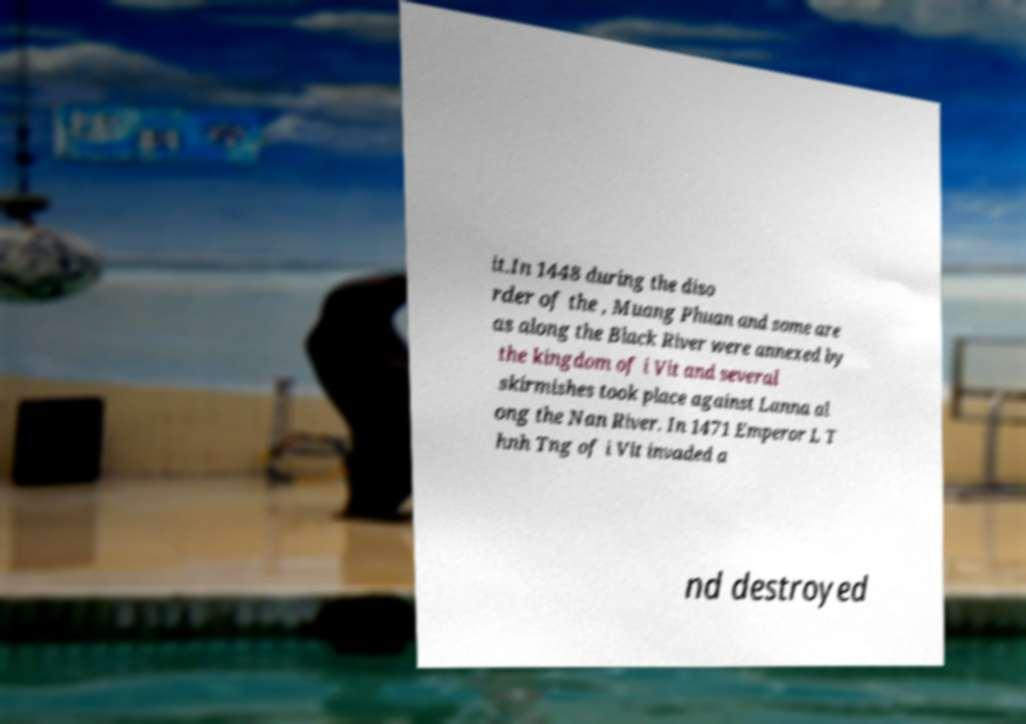Please identify and transcribe the text found in this image. it.In 1448 during the diso rder of the , Muang Phuan and some are as along the Black River were annexed by the kingdom of i Vit and several skirmishes took place against Lanna al ong the Nan River. In 1471 Emperor L T hnh Tng of i Vit invaded a nd destroyed 